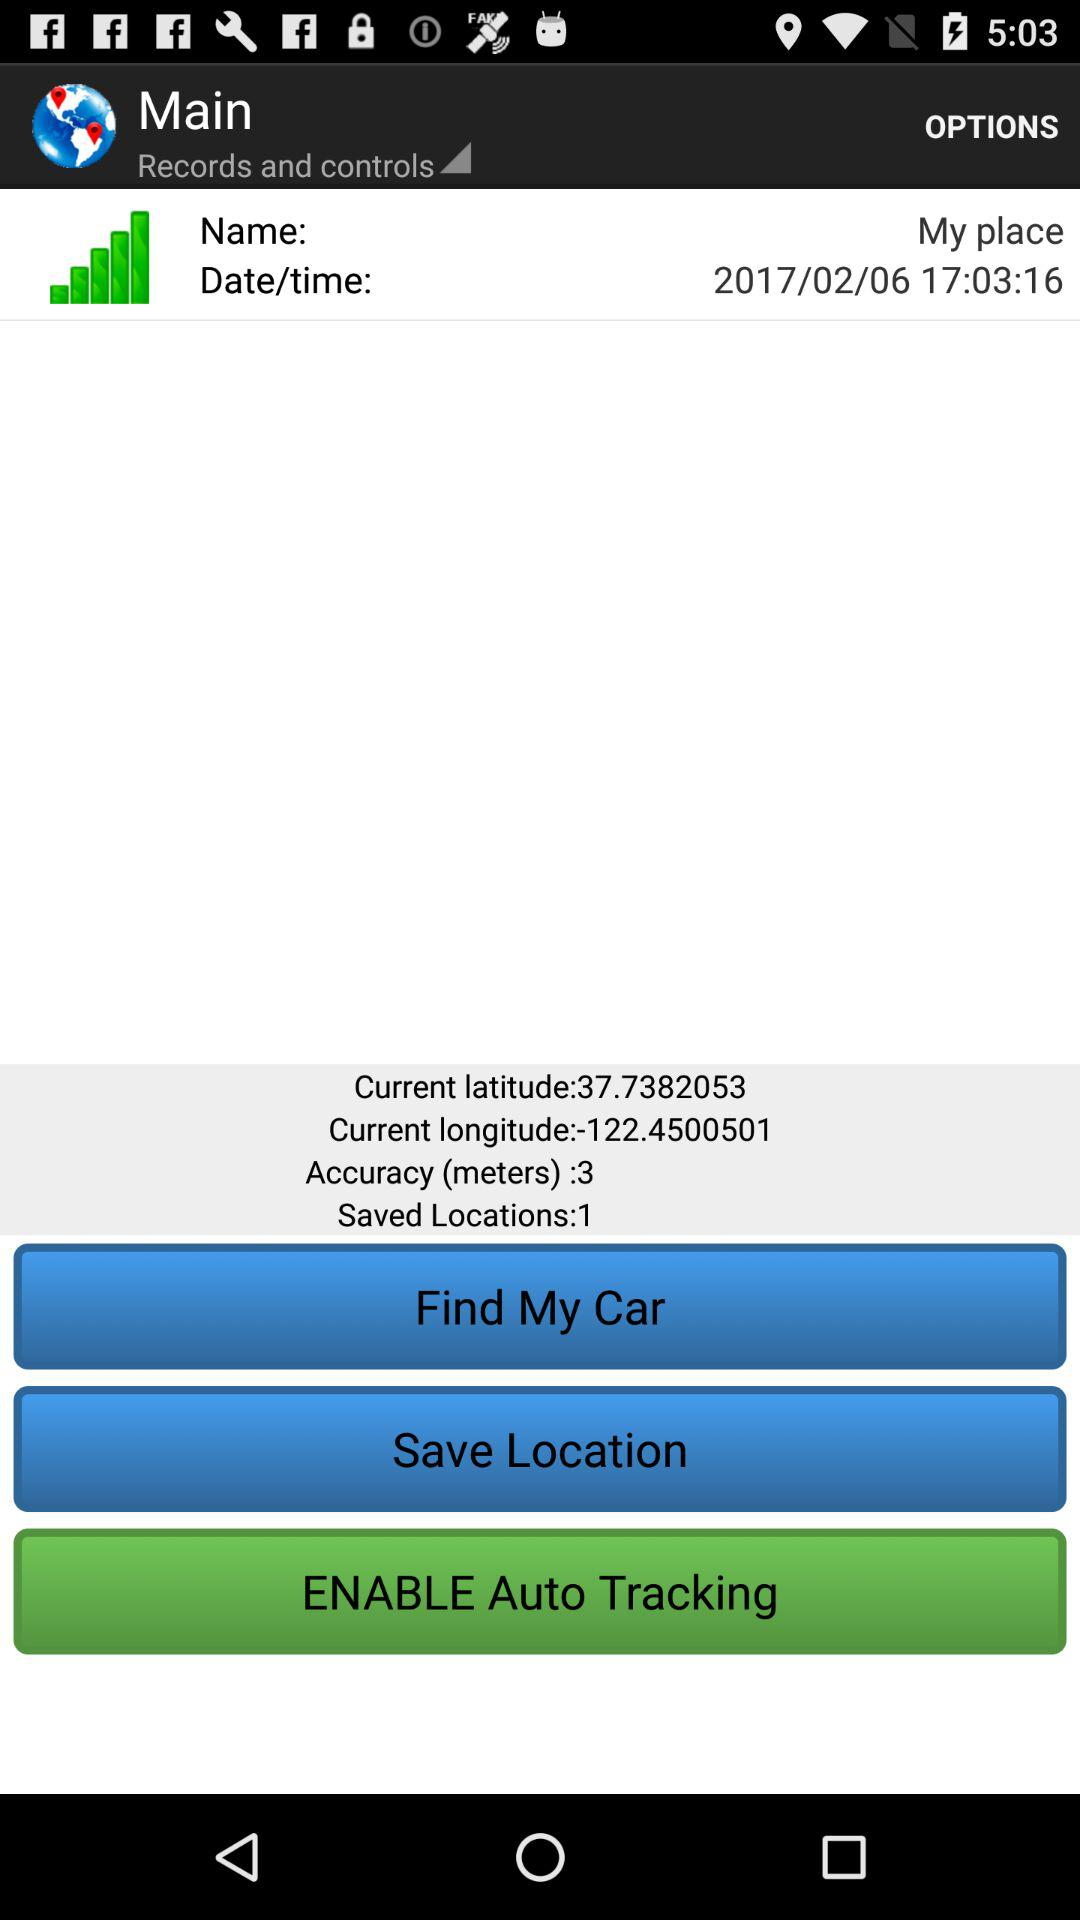What is the shown date and time? The shown date and time are February 6, 2017 and 17:03:16, respectively. 